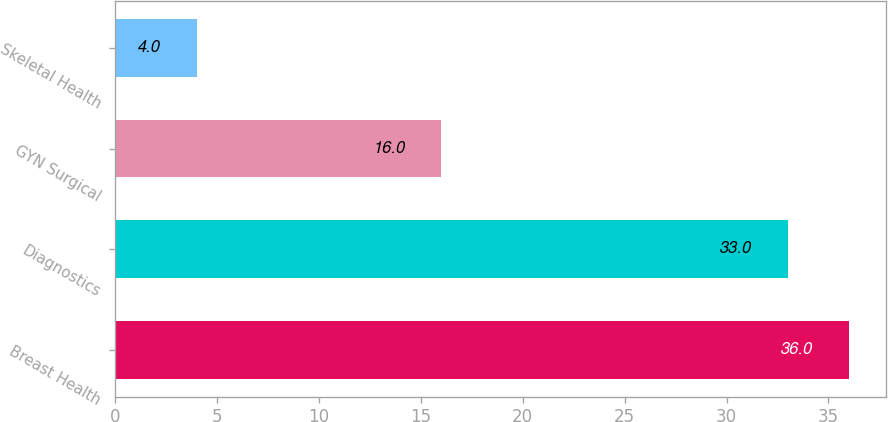Convert chart to OTSL. <chart><loc_0><loc_0><loc_500><loc_500><bar_chart><fcel>Breast Health<fcel>Diagnostics<fcel>GYN Surgical<fcel>Skeletal Health<nl><fcel>36<fcel>33<fcel>16<fcel>4<nl></chart> 